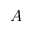<formula> <loc_0><loc_0><loc_500><loc_500>A</formula> 